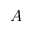<formula> <loc_0><loc_0><loc_500><loc_500>A</formula> 